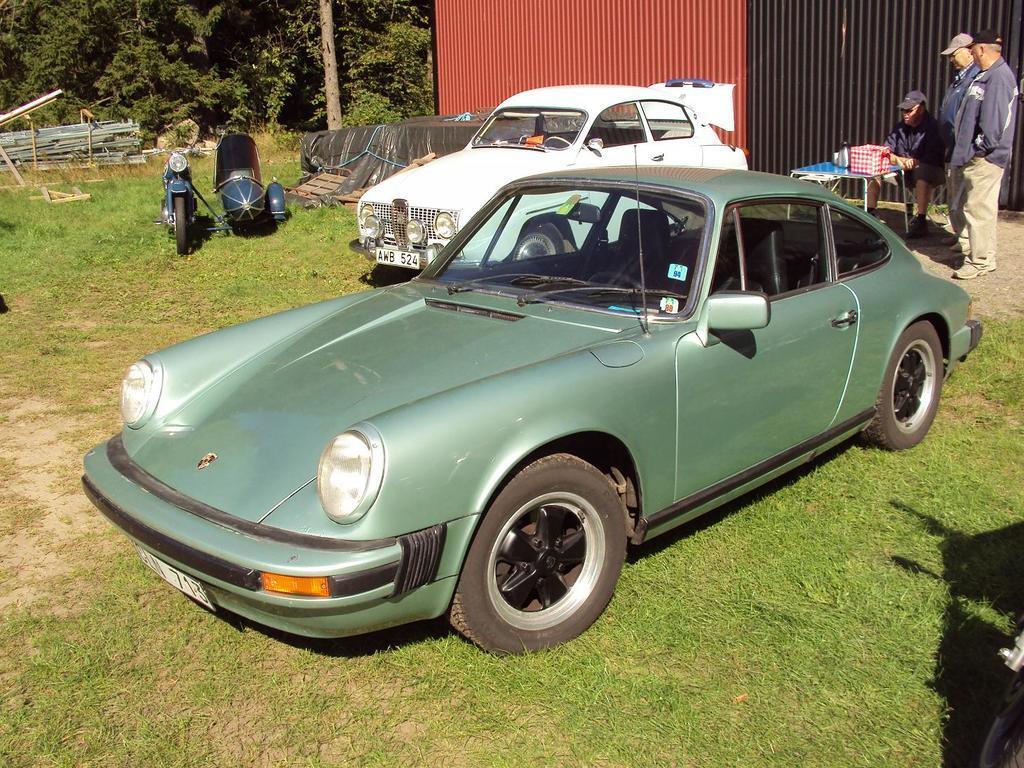How would you summarize this image in a sentence or two? In this image I can see few vehicles and motorbikes. These are on the ground. To the side of these vehicles I can see few people with blue color dresses and also caps. I can see a table and some objects in it. In the back In can see the maroon and black color shade. To the left I can see many trees. 